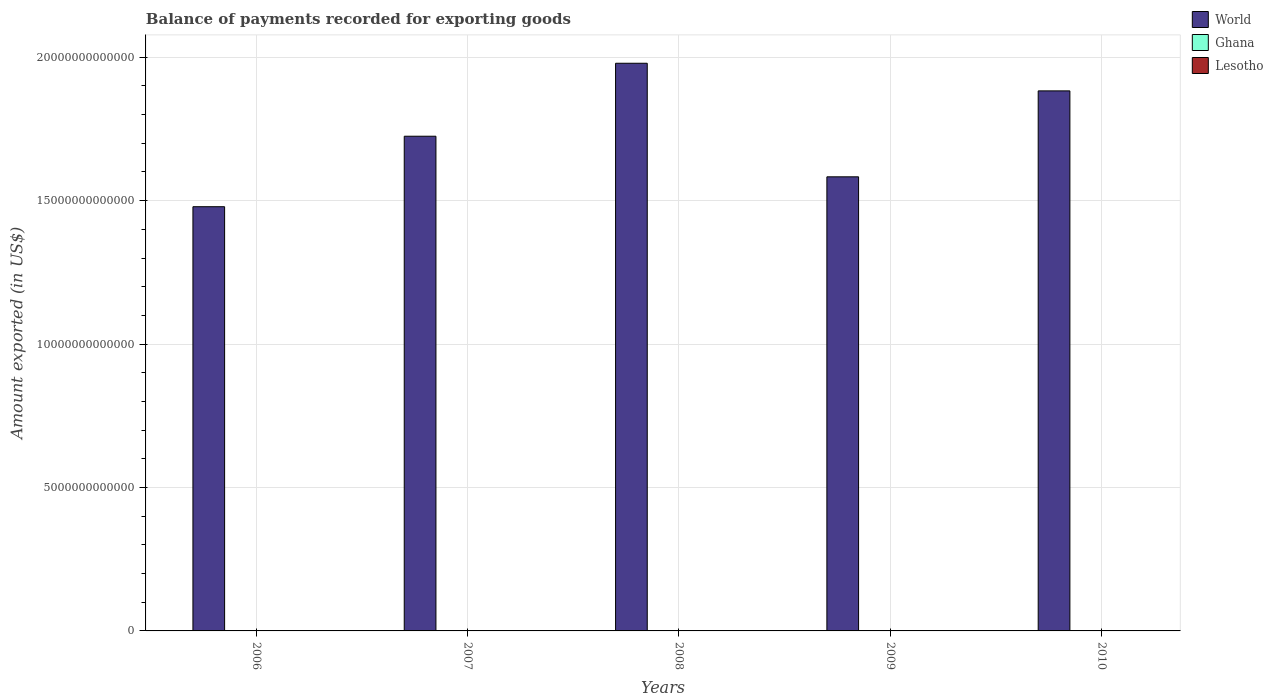How many different coloured bars are there?
Your response must be concise. 3. Are the number of bars per tick equal to the number of legend labels?
Keep it short and to the point. Yes. How many bars are there on the 4th tick from the right?
Make the answer very short. 3. In how many cases, is the number of bars for a given year not equal to the number of legend labels?
Ensure brevity in your answer.  0. What is the amount exported in World in 2008?
Provide a succinct answer. 1.98e+13. Across all years, what is the maximum amount exported in Lesotho?
Keep it short and to the point. 9.32e+08. Across all years, what is the minimum amount exported in Ghana?
Your answer should be very brief. 5.11e+09. In which year was the amount exported in Lesotho minimum?
Provide a short and direct response. 2006. What is the total amount exported in World in the graph?
Keep it short and to the point. 8.65e+13. What is the difference between the amount exported in Lesotho in 2008 and that in 2009?
Your answer should be very brief. 1.57e+08. What is the difference between the amount exported in World in 2010 and the amount exported in Ghana in 2006?
Your answer should be compact. 1.88e+13. What is the average amount exported in Ghana per year?
Keep it short and to the point. 7.05e+09. In the year 2009, what is the difference between the amount exported in Lesotho and amount exported in Ghana?
Offer a terse response. -6.83e+09. What is the ratio of the amount exported in World in 2006 to that in 2008?
Keep it short and to the point. 0.75. Is the amount exported in World in 2007 less than that in 2008?
Provide a succinct answer. Yes. Is the difference between the amount exported in Lesotho in 2007 and 2008 greater than the difference between the amount exported in Ghana in 2007 and 2008?
Your answer should be compact. Yes. What is the difference between the highest and the second highest amount exported in World?
Provide a succinct answer. 9.63e+11. What is the difference between the highest and the lowest amount exported in Lesotho?
Ensure brevity in your answer.  1.75e+08. What does the 3rd bar from the left in 2007 represents?
Give a very brief answer. Lesotho. How many bars are there?
Your answer should be compact. 15. Are all the bars in the graph horizontal?
Your response must be concise. No. What is the difference between two consecutive major ticks on the Y-axis?
Your answer should be compact. 5.00e+12. Are the values on the major ticks of Y-axis written in scientific E-notation?
Offer a very short reply. No. Does the graph contain any zero values?
Your response must be concise. No. Where does the legend appear in the graph?
Offer a terse response. Top right. How many legend labels are there?
Offer a very short reply. 3. How are the legend labels stacked?
Keep it short and to the point. Vertical. What is the title of the graph?
Your response must be concise. Balance of payments recorded for exporting goods. What is the label or title of the X-axis?
Provide a short and direct response. Years. What is the label or title of the Y-axis?
Make the answer very short. Amount exported (in US$). What is the Amount exported (in US$) of World in 2006?
Your answer should be very brief. 1.48e+13. What is the Amount exported (in US$) in Ghana in 2006?
Make the answer very short. 5.11e+09. What is the Amount exported (in US$) of Lesotho in 2006?
Provide a short and direct response. 7.57e+08. What is the Amount exported (in US$) of World in 2007?
Offer a terse response. 1.72e+13. What is the Amount exported (in US$) in Ghana in 2007?
Offer a very short reply. 6.00e+09. What is the Amount exported (in US$) of Lesotho in 2007?
Give a very brief answer. 8.72e+08. What is the Amount exported (in US$) in World in 2008?
Give a very brief answer. 1.98e+13. What is the Amount exported (in US$) of Ghana in 2008?
Your response must be concise. 7.07e+09. What is the Amount exported (in US$) of Lesotho in 2008?
Your answer should be compact. 9.32e+08. What is the Amount exported (in US$) of World in 2009?
Your response must be concise. 1.58e+13. What is the Amount exported (in US$) of Ghana in 2009?
Your answer should be compact. 7.61e+09. What is the Amount exported (in US$) of Lesotho in 2009?
Provide a short and direct response. 7.76e+08. What is the Amount exported (in US$) of World in 2010?
Offer a very short reply. 1.88e+13. What is the Amount exported (in US$) of Ghana in 2010?
Make the answer very short. 9.44e+09. What is the Amount exported (in US$) of Lesotho in 2010?
Your answer should be compact. 9.25e+08. Across all years, what is the maximum Amount exported (in US$) of World?
Ensure brevity in your answer.  1.98e+13. Across all years, what is the maximum Amount exported (in US$) in Ghana?
Provide a succinct answer. 9.44e+09. Across all years, what is the maximum Amount exported (in US$) of Lesotho?
Provide a short and direct response. 9.32e+08. Across all years, what is the minimum Amount exported (in US$) in World?
Keep it short and to the point. 1.48e+13. Across all years, what is the minimum Amount exported (in US$) of Ghana?
Provide a succinct answer. 5.11e+09. Across all years, what is the minimum Amount exported (in US$) of Lesotho?
Your answer should be very brief. 7.57e+08. What is the total Amount exported (in US$) in World in the graph?
Your answer should be very brief. 8.65e+13. What is the total Amount exported (in US$) in Ghana in the graph?
Your answer should be very brief. 3.52e+1. What is the total Amount exported (in US$) of Lesotho in the graph?
Your answer should be compact. 4.26e+09. What is the difference between the Amount exported (in US$) in World in 2006 and that in 2007?
Your answer should be very brief. -2.46e+12. What is the difference between the Amount exported (in US$) in Ghana in 2006 and that in 2007?
Offer a terse response. -8.94e+08. What is the difference between the Amount exported (in US$) in Lesotho in 2006 and that in 2007?
Provide a short and direct response. -1.15e+08. What is the difference between the Amount exported (in US$) of World in 2006 and that in 2008?
Provide a short and direct response. -5.00e+12. What is the difference between the Amount exported (in US$) in Ghana in 2006 and that in 2008?
Offer a very short reply. -1.96e+09. What is the difference between the Amount exported (in US$) of Lesotho in 2006 and that in 2008?
Offer a terse response. -1.75e+08. What is the difference between the Amount exported (in US$) in World in 2006 and that in 2009?
Your answer should be very brief. -1.04e+12. What is the difference between the Amount exported (in US$) in Ghana in 2006 and that in 2009?
Ensure brevity in your answer.  -2.50e+09. What is the difference between the Amount exported (in US$) of Lesotho in 2006 and that in 2009?
Keep it short and to the point. -1.87e+07. What is the difference between the Amount exported (in US$) in World in 2006 and that in 2010?
Offer a very short reply. -4.04e+12. What is the difference between the Amount exported (in US$) in Ghana in 2006 and that in 2010?
Your answer should be compact. -4.33e+09. What is the difference between the Amount exported (in US$) in Lesotho in 2006 and that in 2010?
Offer a very short reply. -1.68e+08. What is the difference between the Amount exported (in US$) in World in 2007 and that in 2008?
Offer a very short reply. -2.54e+12. What is the difference between the Amount exported (in US$) of Ghana in 2007 and that in 2008?
Give a very brief answer. -1.07e+09. What is the difference between the Amount exported (in US$) of Lesotho in 2007 and that in 2008?
Provide a short and direct response. -6.01e+07. What is the difference between the Amount exported (in US$) of World in 2007 and that in 2009?
Give a very brief answer. 1.41e+12. What is the difference between the Amount exported (in US$) in Ghana in 2007 and that in 2009?
Offer a very short reply. -1.61e+09. What is the difference between the Amount exported (in US$) in Lesotho in 2007 and that in 2009?
Offer a very short reply. 9.66e+07. What is the difference between the Amount exported (in US$) of World in 2007 and that in 2010?
Your response must be concise. -1.58e+12. What is the difference between the Amount exported (in US$) in Ghana in 2007 and that in 2010?
Ensure brevity in your answer.  -3.43e+09. What is the difference between the Amount exported (in US$) in Lesotho in 2007 and that in 2010?
Your answer should be compact. -5.31e+07. What is the difference between the Amount exported (in US$) in World in 2008 and that in 2009?
Provide a succinct answer. 3.96e+12. What is the difference between the Amount exported (in US$) in Ghana in 2008 and that in 2009?
Your answer should be compact. -5.39e+08. What is the difference between the Amount exported (in US$) in Lesotho in 2008 and that in 2009?
Your answer should be very brief. 1.57e+08. What is the difference between the Amount exported (in US$) of World in 2008 and that in 2010?
Your answer should be very brief. 9.63e+11. What is the difference between the Amount exported (in US$) in Ghana in 2008 and that in 2010?
Your response must be concise. -2.37e+09. What is the difference between the Amount exported (in US$) in Lesotho in 2008 and that in 2010?
Give a very brief answer. 7.00e+06. What is the difference between the Amount exported (in US$) of World in 2009 and that in 2010?
Ensure brevity in your answer.  -3.00e+12. What is the difference between the Amount exported (in US$) in Ghana in 2009 and that in 2010?
Provide a short and direct response. -1.83e+09. What is the difference between the Amount exported (in US$) of Lesotho in 2009 and that in 2010?
Offer a terse response. -1.50e+08. What is the difference between the Amount exported (in US$) in World in 2006 and the Amount exported (in US$) in Ghana in 2007?
Ensure brevity in your answer.  1.48e+13. What is the difference between the Amount exported (in US$) of World in 2006 and the Amount exported (in US$) of Lesotho in 2007?
Offer a terse response. 1.48e+13. What is the difference between the Amount exported (in US$) of Ghana in 2006 and the Amount exported (in US$) of Lesotho in 2007?
Your answer should be compact. 4.24e+09. What is the difference between the Amount exported (in US$) of World in 2006 and the Amount exported (in US$) of Ghana in 2008?
Offer a very short reply. 1.48e+13. What is the difference between the Amount exported (in US$) of World in 2006 and the Amount exported (in US$) of Lesotho in 2008?
Make the answer very short. 1.48e+13. What is the difference between the Amount exported (in US$) of Ghana in 2006 and the Amount exported (in US$) of Lesotho in 2008?
Provide a succinct answer. 4.18e+09. What is the difference between the Amount exported (in US$) of World in 2006 and the Amount exported (in US$) of Ghana in 2009?
Ensure brevity in your answer.  1.48e+13. What is the difference between the Amount exported (in US$) of World in 2006 and the Amount exported (in US$) of Lesotho in 2009?
Give a very brief answer. 1.48e+13. What is the difference between the Amount exported (in US$) of Ghana in 2006 and the Amount exported (in US$) of Lesotho in 2009?
Offer a terse response. 4.33e+09. What is the difference between the Amount exported (in US$) of World in 2006 and the Amount exported (in US$) of Ghana in 2010?
Your answer should be compact. 1.48e+13. What is the difference between the Amount exported (in US$) of World in 2006 and the Amount exported (in US$) of Lesotho in 2010?
Make the answer very short. 1.48e+13. What is the difference between the Amount exported (in US$) of Ghana in 2006 and the Amount exported (in US$) of Lesotho in 2010?
Make the answer very short. 4.18e+09. What is the difference between the Amount exported (in US$) in World in 2007 and the Amount exported (in US$) in Ghana in 2008?
Ensure brevity in your answer.  1.72e+13. What is the difference between the Amount exported (in US$) of World in 2007 and the Amount exported (in US$) of Lesotho in 2008?
Keep it short and to the point. 1.72e+13. What is the difference between the Amount exported (in US$) in Ghana in 2007 and the Amount exported (in US$) in Lesotho in 2008?
Provide a succinct answer. 5.07e+09. What is the difference between the Amount exported (in US$) in World in 2007 and the Amount exported (in US$) in Ghana in 2009?
Provide a short and direct response. 1.72e+13. What is the difference between the Amount exported (in US$) in World in 2007 and the Amount exported (in US$) in Lesotho in 2009?
Give a very brief answer. 1.72e+13. What is the difference between the Amount exported (in US$) in Ghana in 2007 and the Amount exported (in US$) in Lesotho in 2009?
Your answer should be compact. 5.23e+09. What is the difference between the Amount exported (in US$) of World in 2007 and the Amount exported (in US$) of Ghana in 2010?
Give a very brief answer. 1.72e+13. What is the difference between the Amount exported (in US$) of World in 2007 and the Amount exported (in US$) of Lesotho in 2010?
Your answer should be very brief. 1.72e+13. What is the difference between the Amount exported (in US$) of Ghana in 2007 and the Amount exported (in US$) of Lesotho in 2010?
Your response must be concise. 5.08e+09. What is the difference between the Amount exported (in US$) of World in 2008 and the Amount exported (in US$) of Ghana in 2009?
Offer a very short reply. 1.98e+13. What is the difference between the Amount exported (in US$) in World in 2008 and the Amount exported (in US$) in Lesotho in 2009?
Ensure brevity in your answer.  1.98e+13. What is the difference between the Amount exported (in US$) in Ghana in 2008 and the Amount exported (in US$) in Lesotho in 2009?
Your answer should be compact. 6.29e+09. What is the difference between the Amount exported (in US$) of World in 2008 and the Amount exported (in US$) of Ghana in 2010?
Your response must be concise. 1.98e+13. What is the difference between the Amount exported (in US$) in World in 2008 and the Amount exported (in US$) in Lesotho in 2010?
Provide a succinct answer. 1.98e+13. What is the difference between the Amount exported (in US$) of Ghana in 2008 and the Amount exported (in US$) of Lesotho in 2010?
Keep it short and to the point. 6.15e+09. What is the difference between the Amount exported (in US$) in World in 2009 and the Amount exported (in US$) in Ghana in 2010?
Offer a terse response. 1.58e+13. What is the difference between the Amount exported (in US$) in World in 2009 and the Amount exported (in US$) in Lesotho in 2010?
Give a very brief answer. 1.58e+13. What is the difference between the Amount exported (in US$) of Ghana in 2009 and the Amount exported (in US$) of Lesotho in 2010?
Offer a very short reply. 6.68e+09. What is the average Amount exported (in US$) of World per year?
Your answer should be very brief. 1.73e+13. What is the average Amount exported (in US$) in Ghana per year?
Your answer should be compact. 7.05e+09. What is the average Amount exported (in US$) in Lesotho per year?
Make the answer very short. 8.53e+08. In the year 2006, what is the difference between the Amount exported (in US$) of World and Amount exported (in US$) of Ghana?
Your answer should be compact. 1.48e+13. In the year 2006, what is the difference between the Amount exported (in US$) of World and Amount exported (in US$) of Lesotho?
Offer a very short reply. 1.48e+13. In the year 2006, what is the difference between the Amount exported (in US$) of Ghana and Amount exported (in US$) of Lesotho?
Give a very brief answer. 4.35e+09. In the year 2007, what is the difference between the Amount exported (in US$) in World and Amount exported (in US$) in Ghana?
Ensure brevity in your answer.  1.72e+13. In the year 2007, what is the difference between the Amount exported (in US$) in World and Amount exported (in US$) in Lesotho?
Your response must be concise. 1.72e+13. In the year 2007, what is the difference between the Amount exported (in US$) of Ghana and Amount exported (in US$) of Lesotho?
Your response must be concise. 5.13e+09. In the year 2008, what is the difference between the Amount exported (in US$) of World and Amount exported (in US$) of Ghana?
Ensure brevity in your answer.  1.98e+13. In the year 2008, what is the difference between the Amount exported (in US$) in World and Amount exported (in US$) in Lesotho?
Ensure brevity in your answer.  1.98e+13. In the year 2008, what is the difference between the Amount exported (in US$) in Ghana and Amount exported (in US$) in Lesotho?
Provide a short and direct response. 6.14e+09. In the year 2009, what is the difference between the Amount exported (in US$) in World and Amount exported (in US$) in Ghana?
Give a very brief answer. 1.58e+13. In the year 2009, what is the difference between the Amount exported (in US$) in World and Amount exported (in US$) in Lesotho?
Your answer should be very brief. 1.58e+13. In the year 2009, what is the difference between the Amount exported (in US$) in Ghana and Amount exported (in US$) in Lesotho?
Your answer should be very brief. 6.83e+09. In the year 2010, what is the difference between the Amount exported (in US$) of World and Amount exported (in US$) of Ghana?
Ensure brevity in your answer.  1.88e+13. In the year 2010, what is the difference between the Amount exported (in US$) of World and Amount exported (in US$) of Lesotho?
Provide a succinct answer. 1.88e+13. In the year 2010, what is the difference between the Amount exported (in US$) in Ghana and Amount exported (in US$) in Lesotho?
Your answer should be very brief. 8.51e+09. What is the ratio of the Amount exported (in US$) of World in 2006 to that in 2007?
Give a very brief answer. 0.86. What is the ratio of the Amount exported (in US$) in Ghana in 2006 to that in 2007?
Provide a succinct answer. 0.85. What is the ratio of the Amount exported (in US$) of Lesotho in 2006 to that in 2007?
Your response must be concise. 0.87. What is the ratio of the Amount exported (in US$) of World in 2006 to that in 2008?
Give a very brief answer. 0.75. What is the ratio of the Amount exported (in US$) of Ghana in 2006 to that in 2008?
Your response must be concise. 0.72. What is the ratio of the Amount exported (in US$) of Lesotho in 2006 to that in 2008?
Your answer should be compact. 0.81. What is the ratio of the Amount exported (in US$) of World in 2006 to that in 2009?
Your answer should be compact. 0.93. What is the ratio of the Amount exported (in US$) of Ghana in 2006 to that in 2009?
Provide a short and direct response. 0.67. What is the ratio of the Amount exported (in US$) in Lesotho in 2006 to that in 2009?
Keep it short and to the point. 0.98. What is the ratio of the Amount exported (in US$) of World in 2006 to that in 2010?
Provide a succinct answer. 0.79. What is the ratio of the Amount exported (in US$) in Ghana in 2006 to that in 2010?
Provide a succinct answer. 0.54. What is the ratio of the Amount exported (in US$) of Lesotho in 2006 to that in 2010?
Offer a very short reply. 0.82. What is the ratio of the Amount exported (in US$) of World in 2007 to that in 2008?
Give a very brief answer. 0.87. What is the ratio of the Amount exported (in US$) of Ghana in 2007 to that in 2008?
Your answer should be very brief. 0.85. What is the ratio of the Amount exported (in US$) in Lesotho in 2007 to that in 2008?
Provide a succinct answer. 0.94. What is the ratio of the Amount exported (in US$) in World in 2007 to that in 2009?
Offer a terse response. 1.09. What is the ratio of the Amount exported (in US$) of Ghana in 2007 to that in 2009?
Offer a terse response. 0.79. What is the ratio of the Amount exported (in US$) of Lesotho in 2007 to that in 2009?
Offer a very short reply. 1.12. What is the ratio of the Amount exported (in US$) of World in 2007 to that in 2010?
Your answer should be compact. 0.92. What is the ratio of the Amount exported (in US$) in Ghana in 2007 to that in 2010?
Offer a terse response. 0.64. What is the ratio of the Amount exported (in US$) in Lesotho in 2007 to that in 2010?
Provide a short and direct response. 0.94. What is the ratio of the Amount exported (in US$) in World in 2008 to that in 2009?
Give a very brief answer. 1.25. What is the ratio of the Amount exported (in US$) in Ghana in 2008 to that in 2009?
Keep it short and to the point. 0.93. What is the ratio of the Amount exported (in US$) in Lesotho in 2008 to that in 2009?
Ensure brevity in your answer.  1.2. What is the ratio of the Amount exported (in US$) in World in 2008 to that in 2010?
Make the answer very short. 1.05. What is the ratio of the Amount exported (in US$) in Ghana in 2008 to that in 2010?
Keep it short and to the point. 0.75. What is the ratio of the Amount exported (in US$) of Lesotho in 2008 to that in 2010?
Offer a terse response. 1.01. What is the ratio of the Amount exported (in US$) in World in 2009 to that in 2010?
Your answer should be very brief. 0.84. What is the ratio of the Amount exported (in US$) in Ghana in 2009 to that in 2010?
Your answer should be compact. 0.81. What is the ratio of the Amount exported (in US$) of Lesotho in 2009 to that in 2010?
Offer a terse response. 0.84. What is the difference between the highest and the second highest Amount exported (in US$) in World?
Keep it short and to the point. 9.63e+11. What is the difference between the highest and the second highest Amount exported (in US$) in Ghana?
Provide a succinct answer. 1.83e+09. What is the difference between the highest and the second highest Amount exported (in US$) of Lesotho?
Offer a terse response. 7.00e+06. What is the difference between the highest and the lowest Amount exported (in US$) in World?
Give a very brief answer. 5.00e+12. What is the difference between the highest and the lowest Amount exported (in US$) in Ghana?
Offer a very short reply. 4.33e+09. What is the difference between the highest and the lowest Amount exported (in US$) in Lesotho?
Make the answer very short. 1.75e+08. 